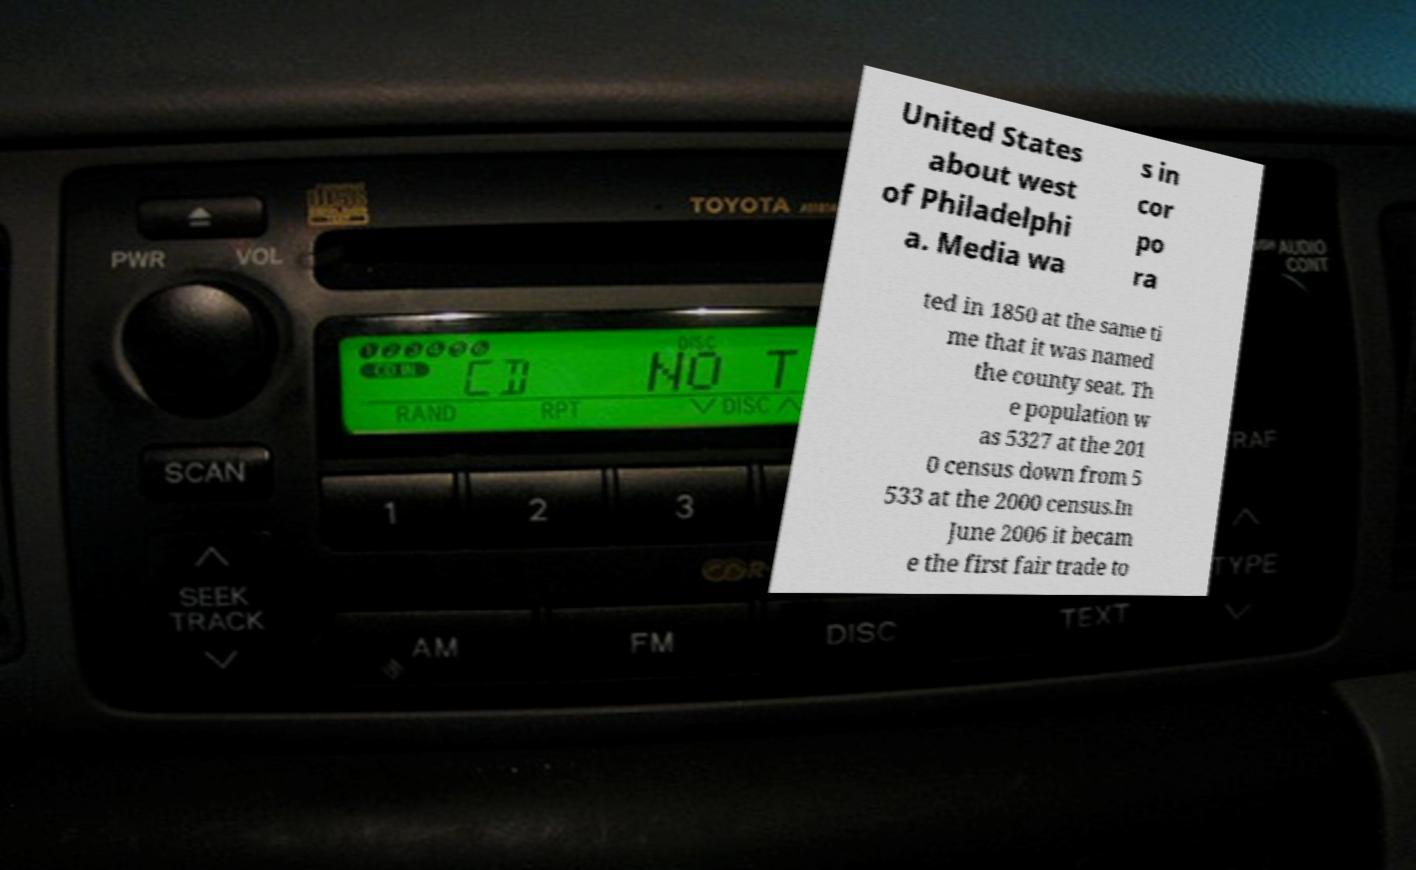Could you assist in decoding the text presented in this image and type it out clearly? United States about west of Philadelphi a. Media wa s in cor po ra ted in 1850 at the same ti me that it was named the county seat. Th e population w as 5327 at the 201 0 census down from 5 533 at the 2000 census.In June 2006 it becam e the first fair trade to 